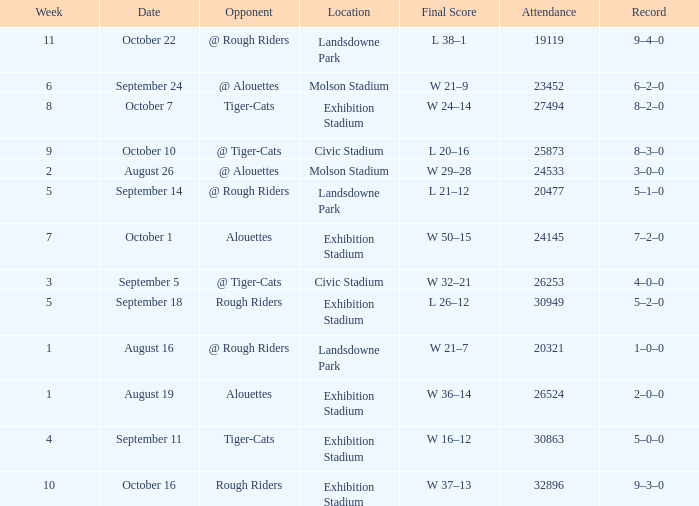What is the least value for week? 1.0. 